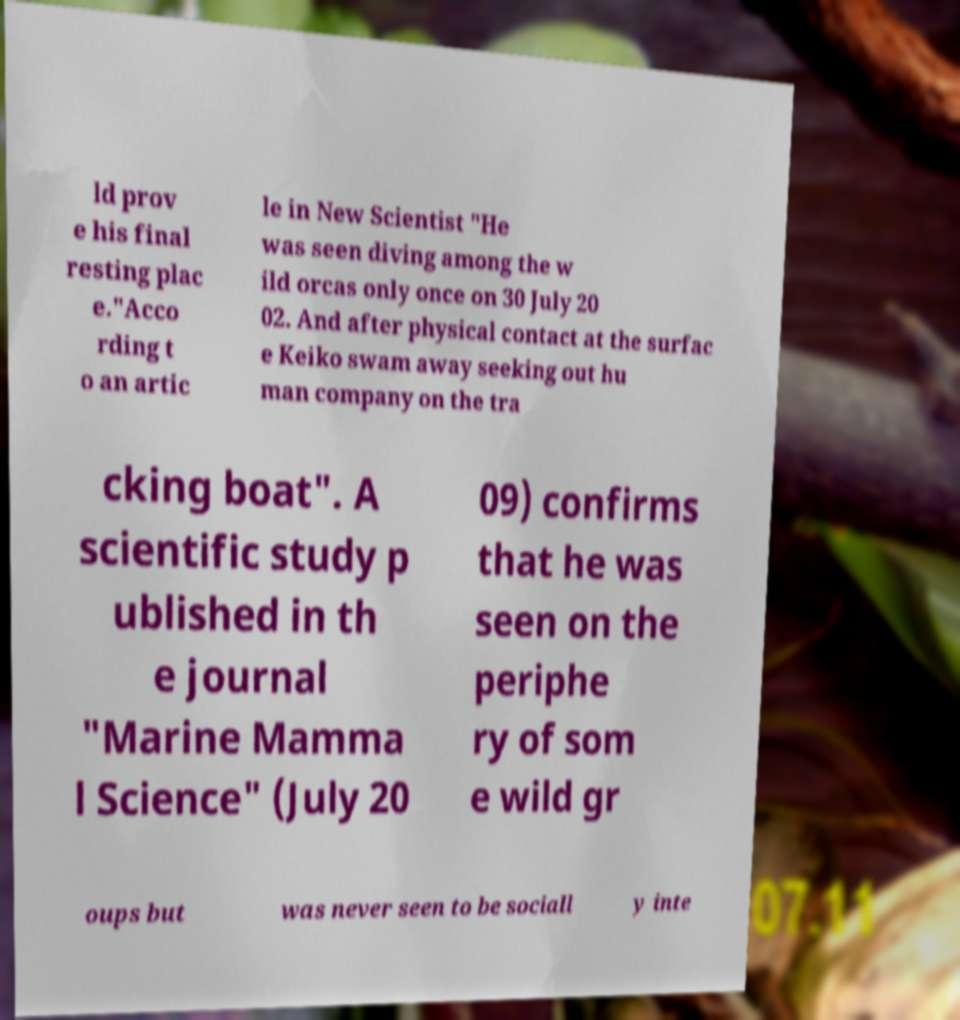Please read and relay the text visible in this image. What does it say? ld prov e his final resting plac e."Acco rding t o an artic le in New Scientist "He was seen diving among the w ild orcas only once on 30 July 20 02. And after physical contact at the surfac e Keiko swam away seeking out hu man company on the tra cking boat". A scientific study p ublished in th e journal "Marine Mamma l Science" (July 20 09) confirms that he was seen on the periphe ry of som e wild gr oups but was never seen to be sociall y inte 